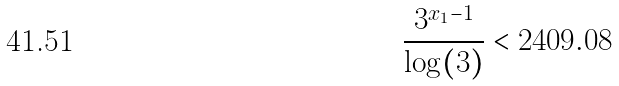<formula> <loc_0><loc_0><loc_500><loc_500>\frac { 3 ^ { x _ { 1 } - 1 } } { \log ( 3 ) } < 2 4 0 9 . 0 8</formula> 